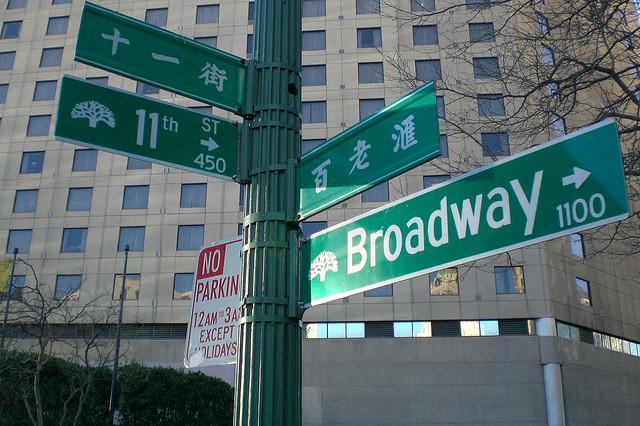What do the symbols on the signs mean?
Keep it brief. Direction. What number is the cross street?
Concise answer only. 11. Are the lights on in the building?
Give a very brief answer. No. Are there flat houses?
Short answer required. No. Is this an English speaking country?
Give a very brief answer. Yes. Are all the signs in English?
Write a very short answer. No. How many signs are rectangular?
Be succinct. 4. 